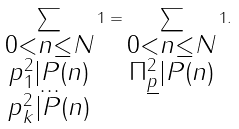<formula> <loc_0><loc_0><loc_500><loc_500>\sum _ { \substack { { 0 < n \leq N } \\ { p _ { 1 } ^ { 2 } | P ( n ) } \\ { \dots } \\ { p _ { k } ^ { 2 } | P ( n ) } } } 1 = \sum _ { \substack { { 0 < n \leq N } \\ { \Pi _ { \underline { p } } ^ { 2 } | P ( n ) } } } 1 .</formula> 